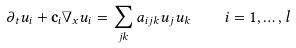<formula> <loc_0><loc_0><loc_500><loc_500>\partial _ { t } u _ { i } + \mathbf c _ { i } \nabla _ { x } u _ { i } = \sum _ { j k } a _ { i j k } u _ { j } u _ { k } \quad i = 1 , \dots , l</formula> 